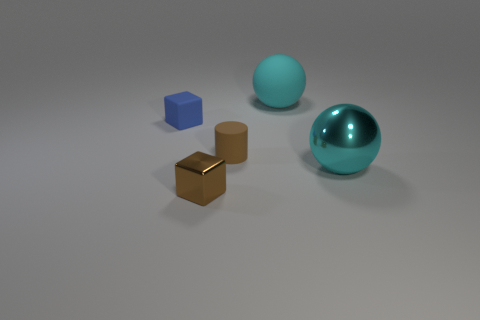There is a block that is the same color as the tiny cylinder; what material is it?
Give a very brief answer. Metal. Are there any spheres that have the same color as the large matte object?
Your response must be concise. Yes. What color is the big thing that is the same material as the small brown cube?
Ensure brevity in your answer.  Cyan. What number of things are either brown cylinders or tiny blue matte blocks?
Make the answer very short. 2. There is another ball that is the same size as the cyan rubber ball; what color is it?
Offer a very short reply. Cyan. What number of things are either spheres behind the cyan metal thing or tiny blue objects?
Your response must be concise. 2. What number of other things are the same size as the metal ball?
Give a very brief answer. 1. What size is the ball that is on the left side of the metallic sphere?
Offer a very short reply. Large. The big cyan object that is made of the same material as the cylinder is what shape?
Your answer should be compact. Sphere. Is there any other thing that has the same color as the rubber block?
Provide a short and direct response. No. 